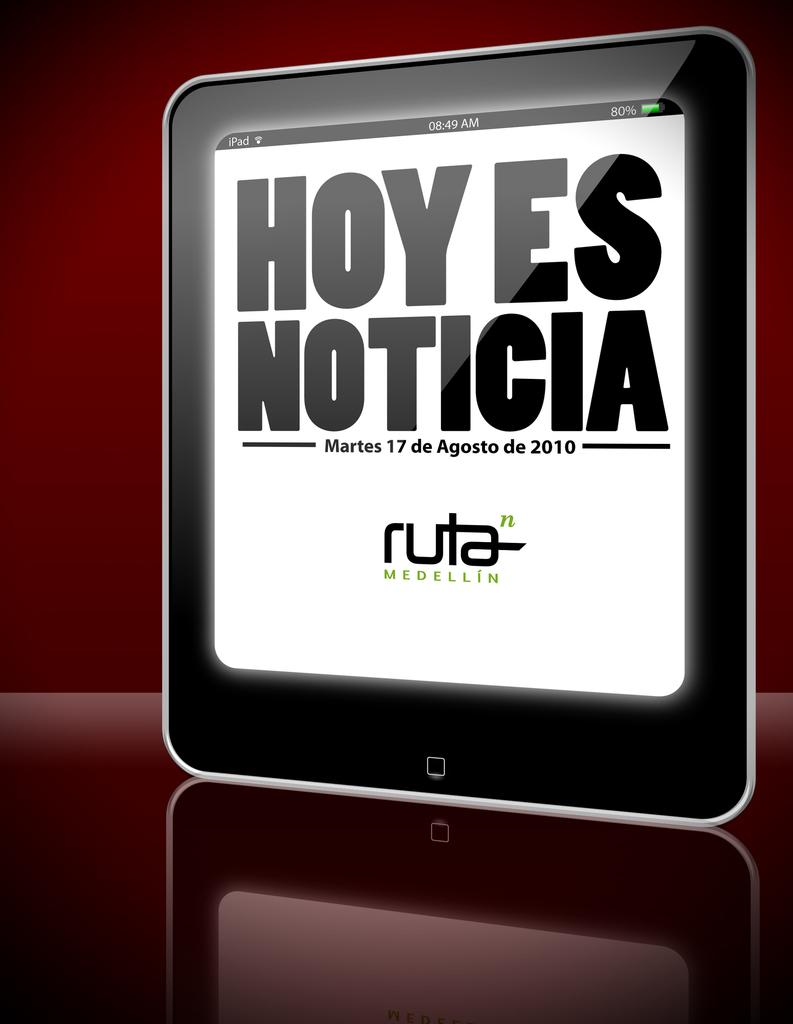What electronic device is visible in the image? There is a tablet in the image. What is displayed on the tablet's screen? The tablet has text displayed on its screen. How many children are visible holding the tablet in the image? There are no children present in the image; it only features a tablet with text displayed on its screen. Are there any men in the image holding the tablet? There is no reference to any men holding the tablet in the image; it only features the tablet with text displayed on its screen. 